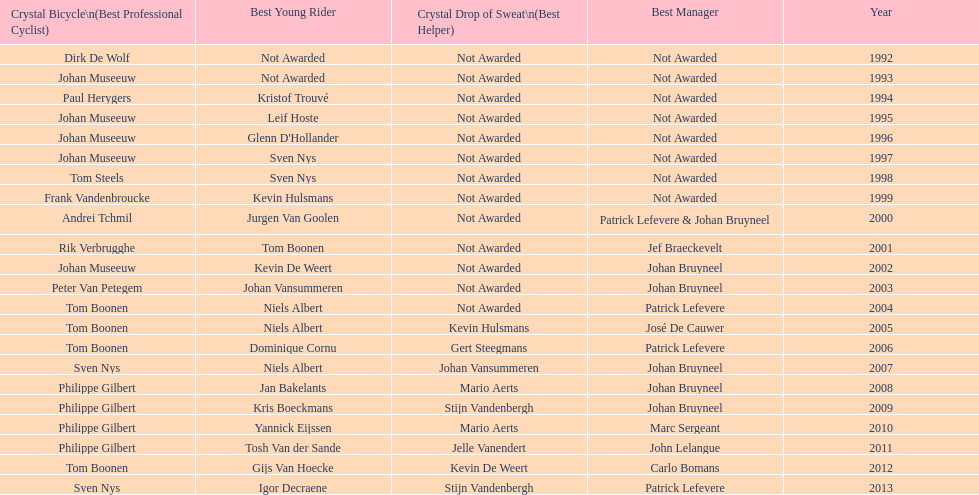How many times does johan bryneel's name show up across all these lists? 6. 